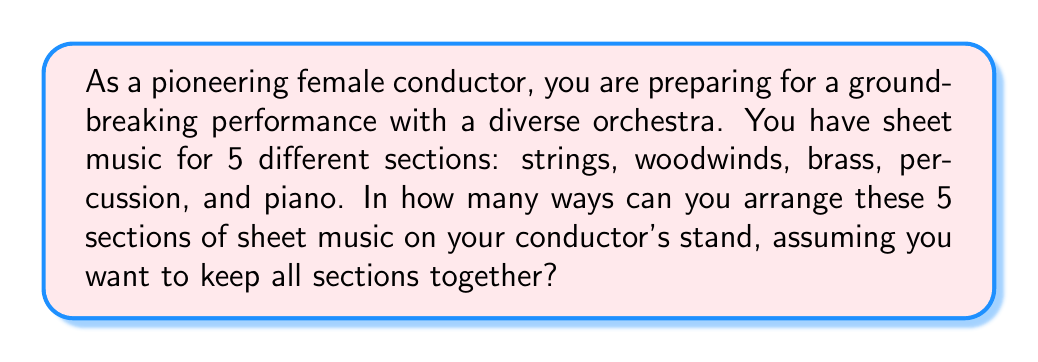Could you help me with this problem? Let's approach this step-by-step:

1) This is a permutation problem. We are arranging 5 distinct items (the 5 sections of sheet music) in a line.

2) The formula for permutations of n distinct objects is:

   $$P(n) = n!$$

   where n! (n factorial) is the product of all positive integers less than or equal to n.

3) In this case, n = 5 (for the 5 sections of sheet music).

4) Therefore, we need to calculate:

   $$P(5) = 5!$$

5) Let's expand this:

   $$5! = 5 \times 4 \times 3 \times 2 \times 1 = 120$$

6) This means there are 120 different ways to arrange the 5 sections of sheet music on the conductor's stand.
Answer: 120 